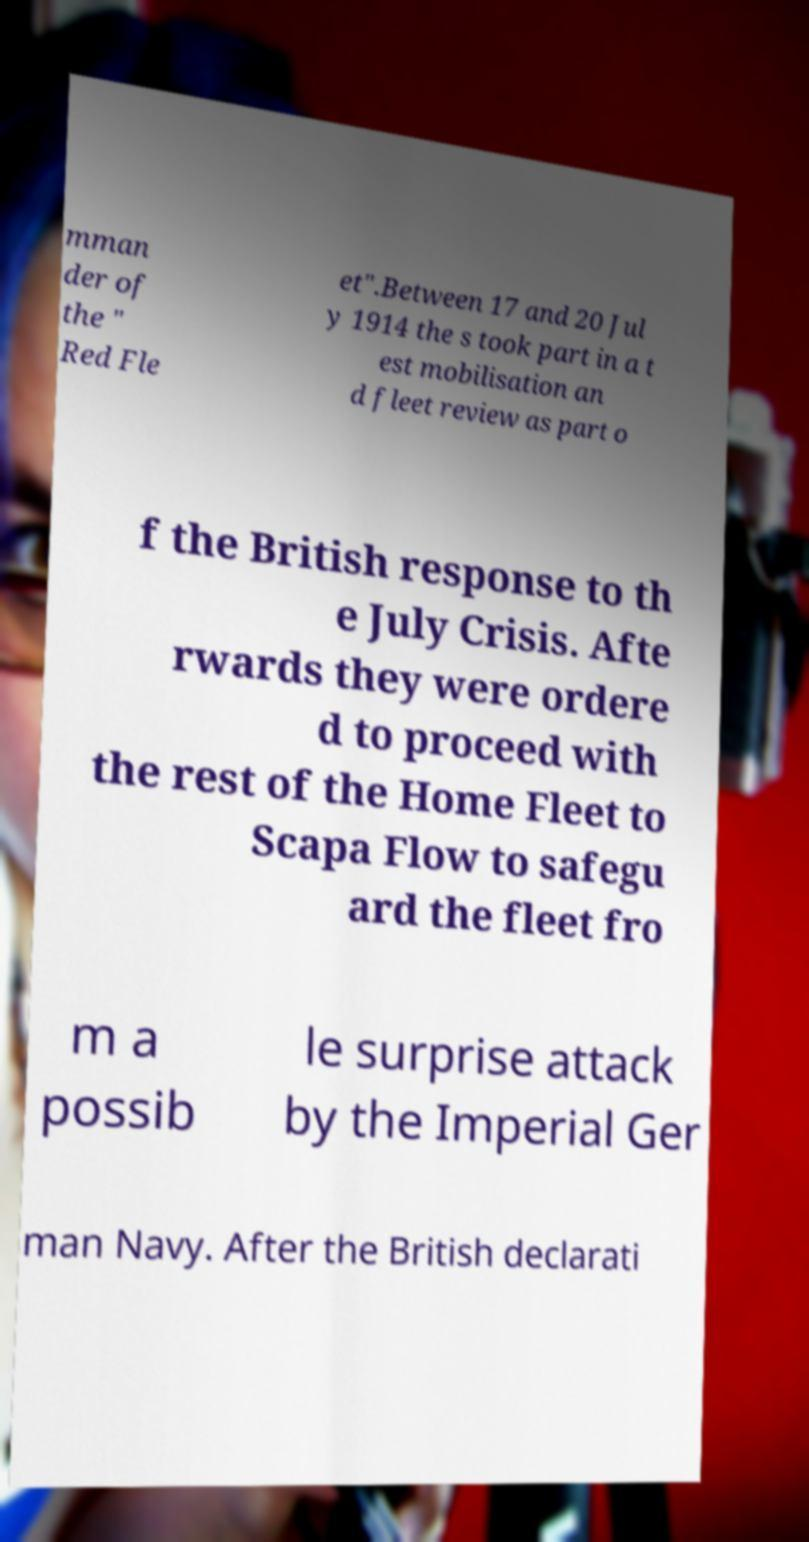What messages or text are displayed in this image? I need them in a readable, typed format. mman der of the " Red Fle et".Between 17 and 20 Jul y 1914 the s took part in a t est mobilisation an d fleet review as part o f the British response to th e July Crisis. Afte rwards they were ordere d to proceed with the rest of the Home Fleet to Scapa Flow to safegu ard the fleet fro m a possib le surprise attack by the Imperial Ger man Navy. After the British declarati 